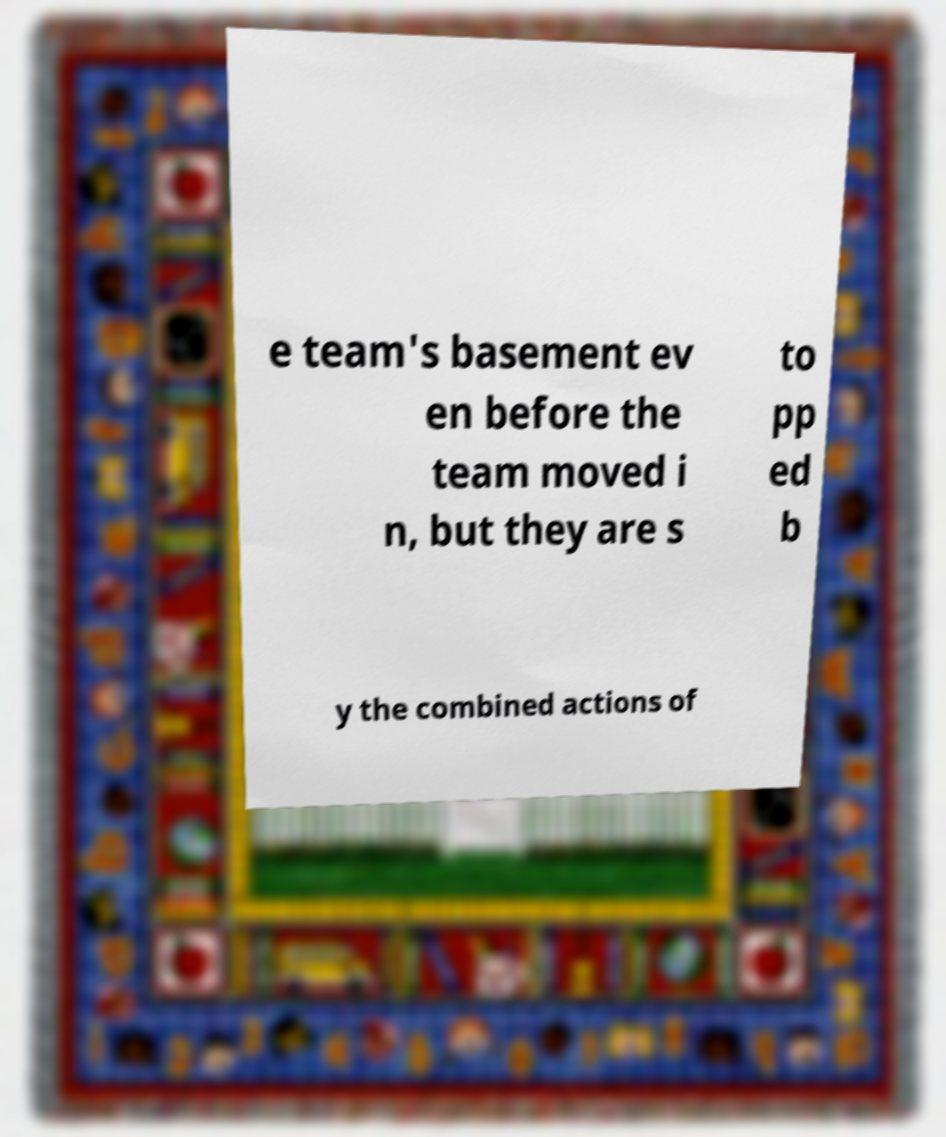There's text embedded in this image that I need extracted. Can you transcribe it verbatim? e team's basement ev en before the team moved i n, but they are s to pp ed b y the combined actions of 